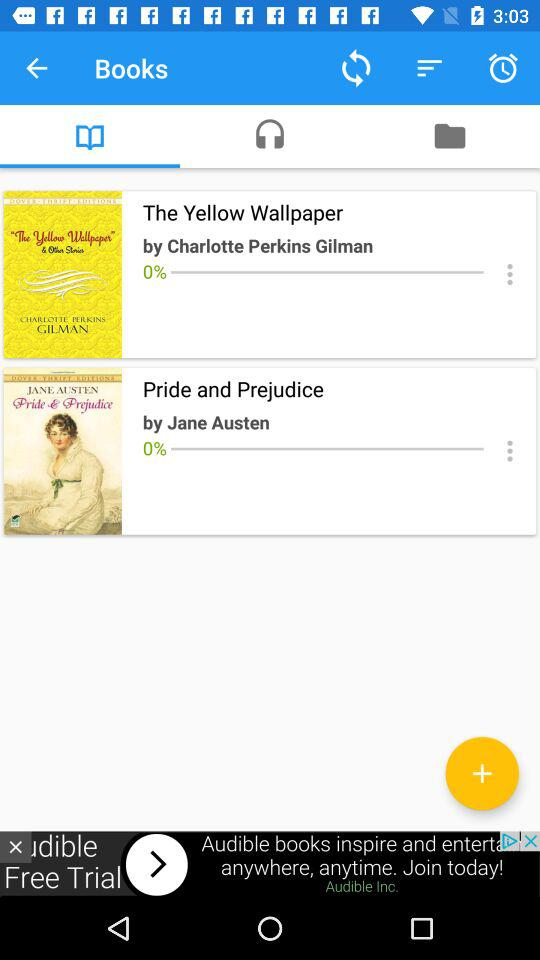How many books have 0% progress?
Answer the question using a single word or phrase. 2 